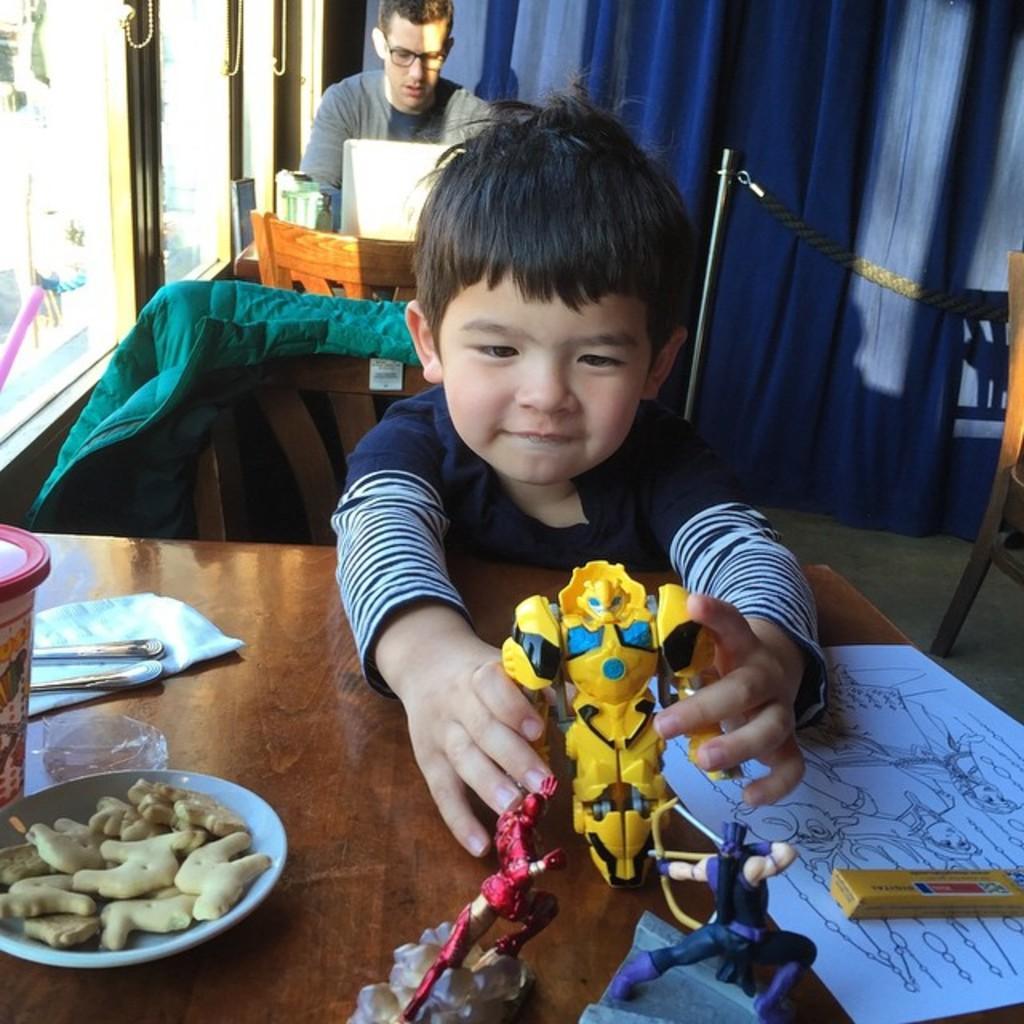How would you summarize this image in a sentence or two? In this image we can see kid. At the bottom there is a table and we can see a plate, tin, toys, napkin, spoons and a paper placed on the table. In the background there is a man sitting and we can see chairs. There is a curtain and we can see a rope. On the left there are windows. 